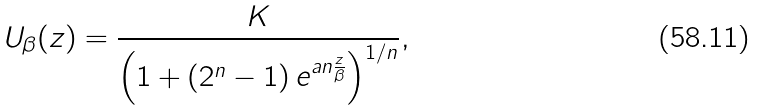<formula> <loc_0><loc_0><loc_500><loc_500>U _ { \beta } ( z ) = \frac { K } { \left ( 1 + \left ( 2 ^ { n } - 1 \right ) e ^ { a n \frac { z } { \beta } } \right ) ^ { 1 / n } } ,</formula> 